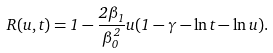<formula> <loc_0><loc_0><loc_500><loc_500>R ( u , t ) = 1 - \frac { 2 \beta _ { 1 } } { \beta _ { 0 } ^ { 2 } } u ( 1 - \gamma - \ln t - \ln u ) .</formula> 